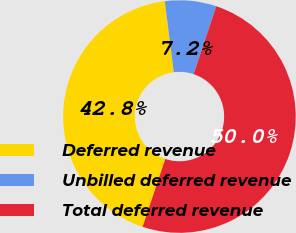<chart> <loc_0><loc_0><loc_500><loc_500><pie_chart><fcel>Deferred revenue<fcel>Unbilled deferred revenue<fcel>Total deferred revenue<nl><fcel>42.85%<fcel>7.15%<fcel>50.0%<nl></chart> 